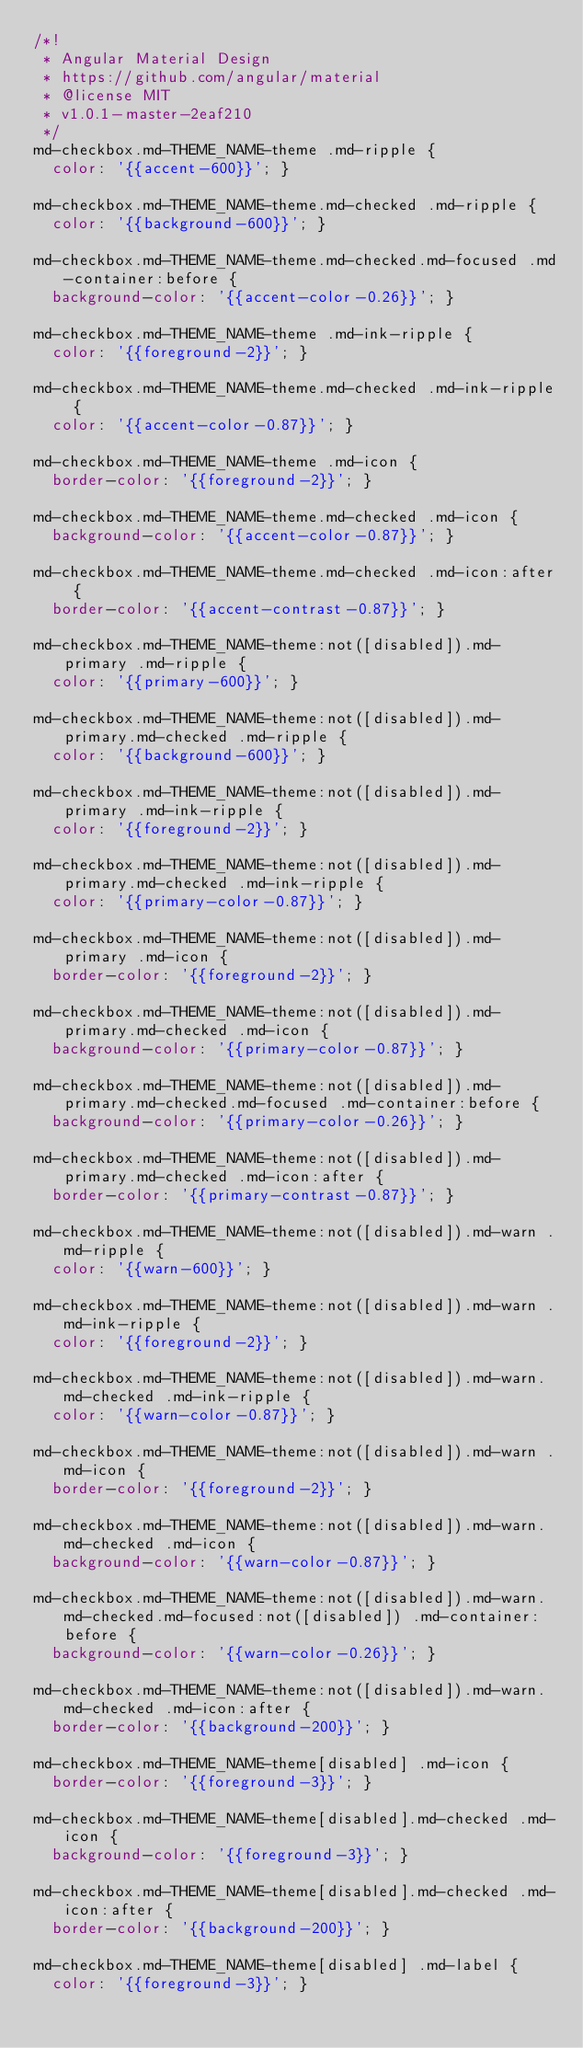<code> <loc_0><loc_0><loc_500><loc_500><_CSS_>/*!
 * Angular Material Design
 * https://github.com/angular/material
 * @license MIT
 * v1.0.1-master-2eaf210
 */
md-checkbox.md-THEME_NAME-theme .md-ripple {
  color: '{{accent-600}}'; }

md-checkbox.md-THEME_NAME-theme.md-checked .md-ripple {
  color: '{{background-600}}'; }

md-checkbox.md-THEME_NAME-theme.md-checked.md-focused .md-container:before {
  background-color: '{{accent-color-0.26}}'; }

md-checkbox.md-THEME_NAME-theme .md-ink-ripple {
  color: '{{foreground-2}}'; }

md-checkbox.md-THEME_NAME-theme.md-checked .md-ink-ripple {
  color: '{{accent-color-0.87}}'; }

md-checkbox.md-THEME_NAME-theme .md-icon {
  border-color: '{{foreground-2}}'; }

md-checkbox.md-THEME_NAME-theme.md-checked .md-icon {
  background-color: '{{accent-color-0.87}}'; }

md-checkbox.md-THEME_NAME-theme.md-checked .md-icon:after {
  border-color: '{{accent-contrast-0.87}}'; }

md-checkbox.md-THEME_NAME-theme:not([disabled]).md-primary .md-ripple {
  color: '{{primary-600}}'; }

md-checkbox.md-THEME_NAME-theme:not([disabled]).md-primary.md-checked .md-ripple {
  color: '{{background-600}}'; }

md-checkbox.md-THEME_NAME-theme:not([disabled]).md-primary .md-ink-ripple {
  color: '{{foreground-2}}'; }

md-checkbox.md-THEME_NAME-theme:not([disabled]).md-primary.md-checked .md-ink-ripple {
  color: '{{primary-color-0.87}}'; }

md-checkbox.md-THEME_NAME-theme:not([disabled]).md-primary .md-icon {
  border-color: '{{foreground-2}}'; }

md-checkbox.md-THEME_NAME-theme:not([disabled]).md-primary.md-checked .md-icon {
  background-color: '{{primary-color-0.87}}'; }

md-checkbox.md-THEME_NAME-theme:not([disabled]).md-primary.md-checked.md-focused .md-container:before {
  background-color: '{{primary-color-0.26}}'; }

md-checkbox.md-THEME_NAME-theme:not([disabled]).md-primary.md-checked .md-icon:after {
  border-color: '{{primary-contrast-0.87}}'; }

md-checkbox.md-THEME_NAME-theme:not([disabled]).md-warn .md-ripple {
  color: '{{warn-600}}'; }

md-checkbox.md-THEME_NAME-theme:not([disabled]).md-warn .md-ink-ripple {
  color: '{{foreground-2}}'; }

md-checkbox.md-THEME_NAME-theme:not([disabled]).md-warn.md-checked .md-ink-ripple {
  color: '{{warn-color-0.87}}'; }

md-checkbox.md-THEME_NAME-theme:not([disabled]).md-warn .md-icon {
  border-color: '{{foreground-2}}'; }

md-checkbox.md-THEME_NAME-theme:not([disabled]).md-warn.md-checked .md-icon {
  background-color: '{{warn-color-0.87}}'; }

md-checkbox.md-THEME_NAME-theme:not([disabled]).md-warn.md-checked.md-focused:not([disabled]) .md-container:before {
  background-color: '{{warn-color-0.26}}'; }

md-checkbox.md-THEME_NAME-theme:not([disabled]).md-warn.md-checked .md-icon:after {
  border-color: '{{background-200}}'; }

md-checkbox.md-THEME_NAME-theme[disabled] .md-icon {
  border-color: '{{foreground-3}}'; }

md-checkbox.md-THEME_NAME-theme[disabled].md-checked .md-icon {
  background-color: '{{foreground-3}}'; }

md-checkbox.md-THEME_NAME-theme[disabled].md-checked .md-icon:after {
  border-color: '{{background-200}}'; }

md-checkbox.md-THEME_NAME-theme[disabled] .md-label {
  color: '{{foreground-3}}'; }
</code> 